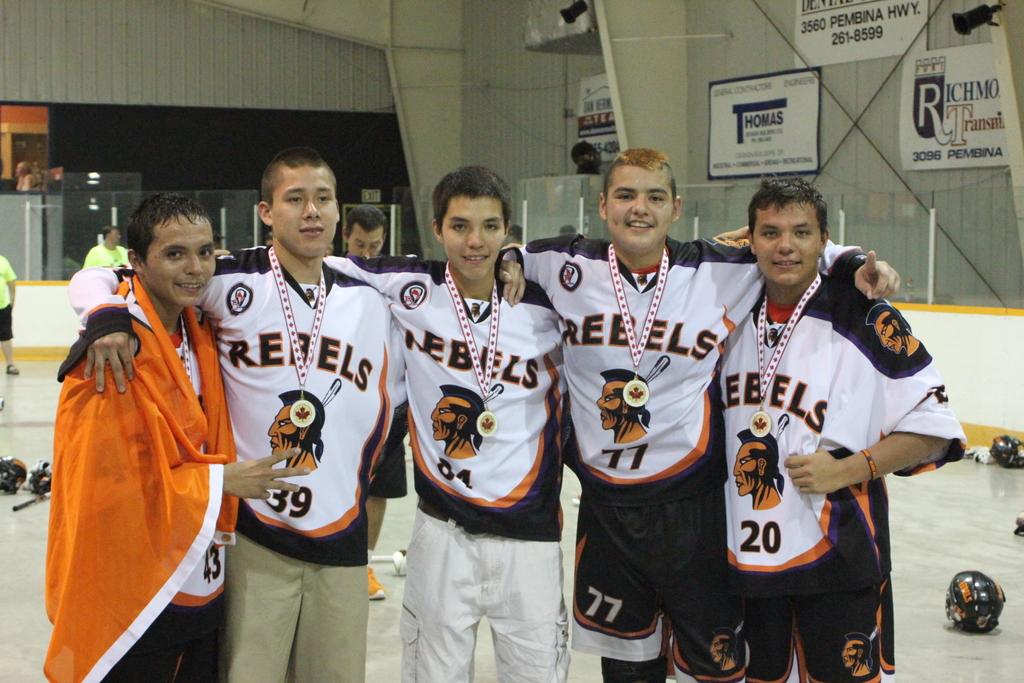What is the team name on the jerseys?
Offer a terse response. Rebels. Players are what game play?
Make the answer very short. Answering does not require reading text in the image. 